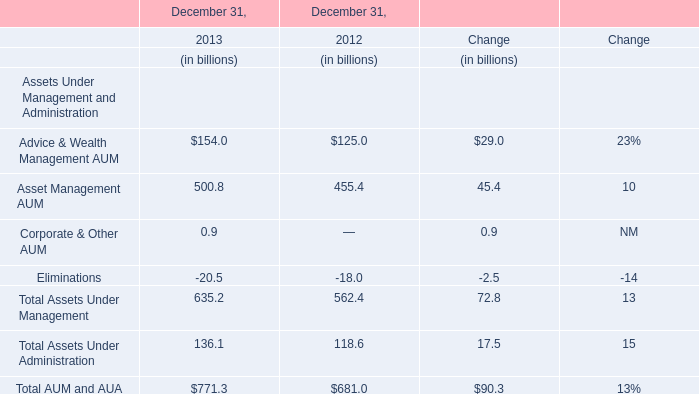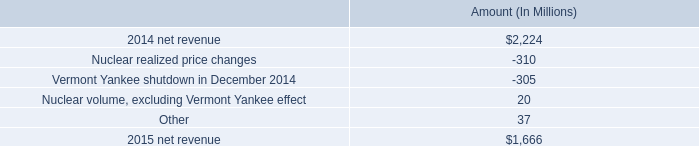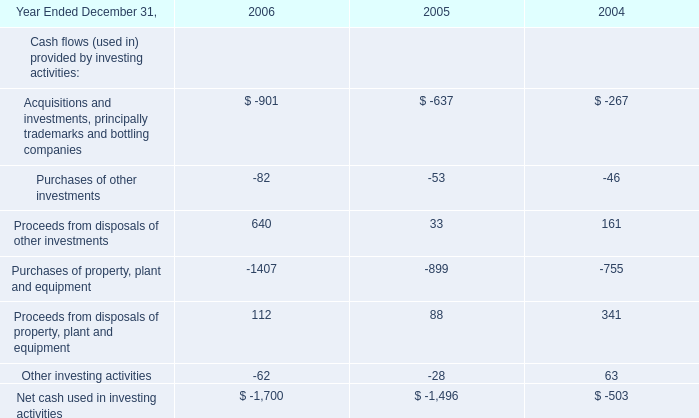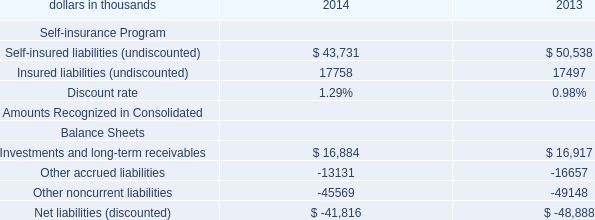In the year with largest amount of Advice & Wealth Management AUM, what's the amount of Advice & Wealth Management AUM and Asset Management AUM for December 31,? (in billion) 
Computations: (154 + 500.8)
Answer: 654.8. 